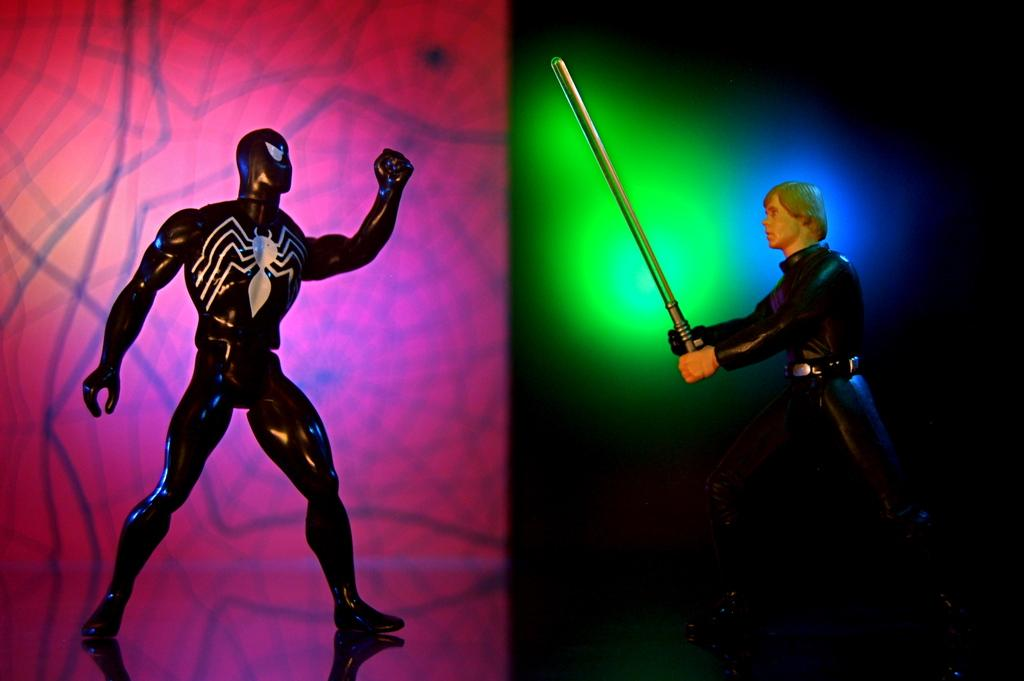How many toys are present in the image? There are two toys in the image. What is the color of the toys? Both toys are black in color. Can you identify one of the toys in the image? Yes, one of the toys is of Spider-Man. What type of knife is being used to cut the circle in the image? There is no knife or circle present in the image; it features two black toys, one of which is Spider-Man. Can you describe the frog's behavior in the image? There is no frog present in the image. 